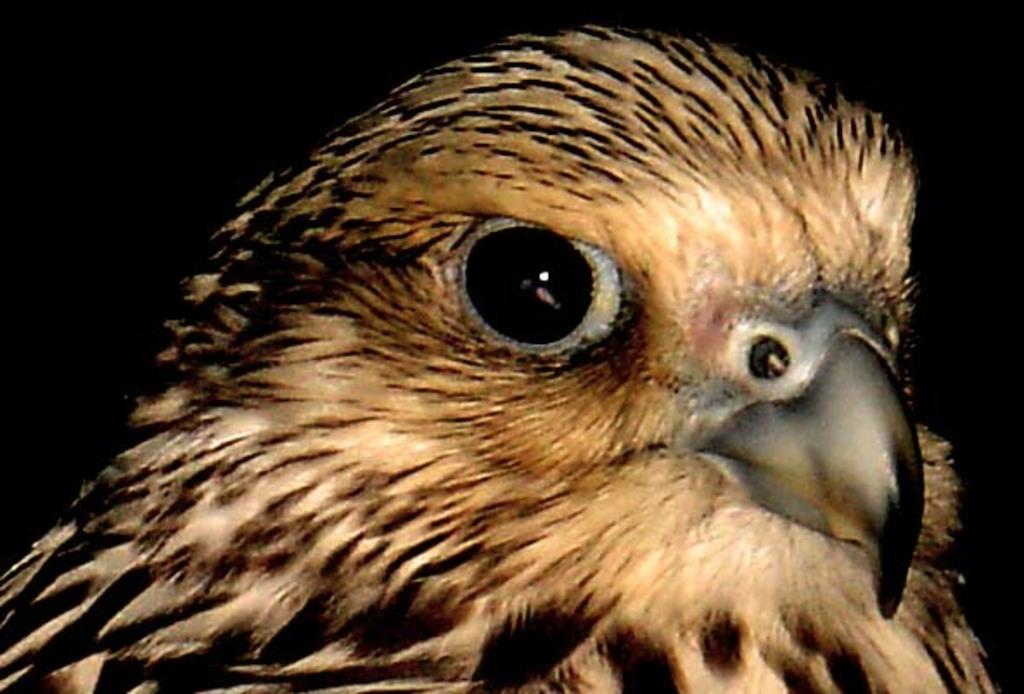What is the main subject of the image? The main subject of the image is a bird. What can be seen in the background of the image? The background of the image is black. What type of pear is hanging from the plant in the image? There is no pear or plant present in the image; it is a close-up of a bird with a black background. What holiday is being celebrated in the image? There is no indication of a holiday being celebrated in the image, as it only features a bird and a black background. 